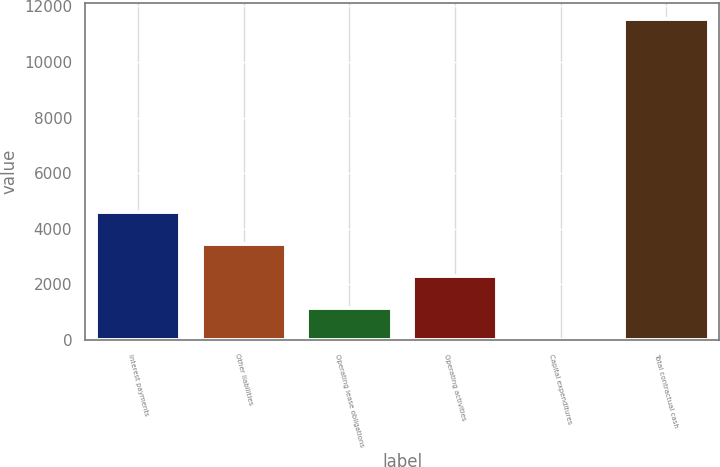Convert chart to OTSL. <chart><loc_0><loc_0><loc_500><loc_500><bar_chart><fcel>Interest payments<fcel>Other liabilities<fcel>Operating lease obligations<fcel>Operating activities<fcel>Capital expenditures<fcel>Total contractual cash<nl><fcel>4619.4<fcel>3464.8<fcel>1155.6<fcel>2310.2<fcel>1<fcel>11547<nl></chart> 